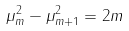<formula> <loc_0><loc_0><loc_500><loc_500>\mu _ { m } ^ { 2 } - \mu _ { m + 1 } ^ { 2 } = 2 m</formula> 